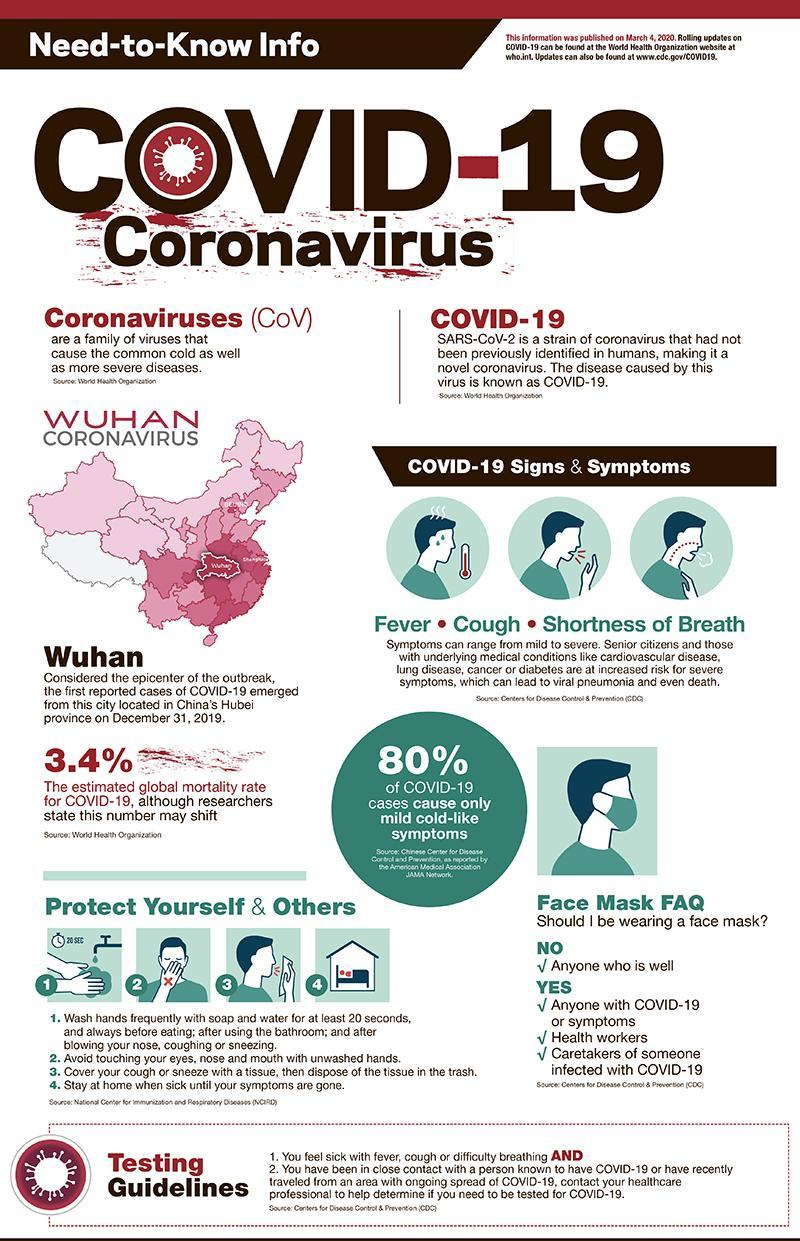What is the estimated global mortality rate for Covid-19?
Answer the question with a short phrase. 3.4% What percentage of Covid-19 causes severe symptoms? 20% 